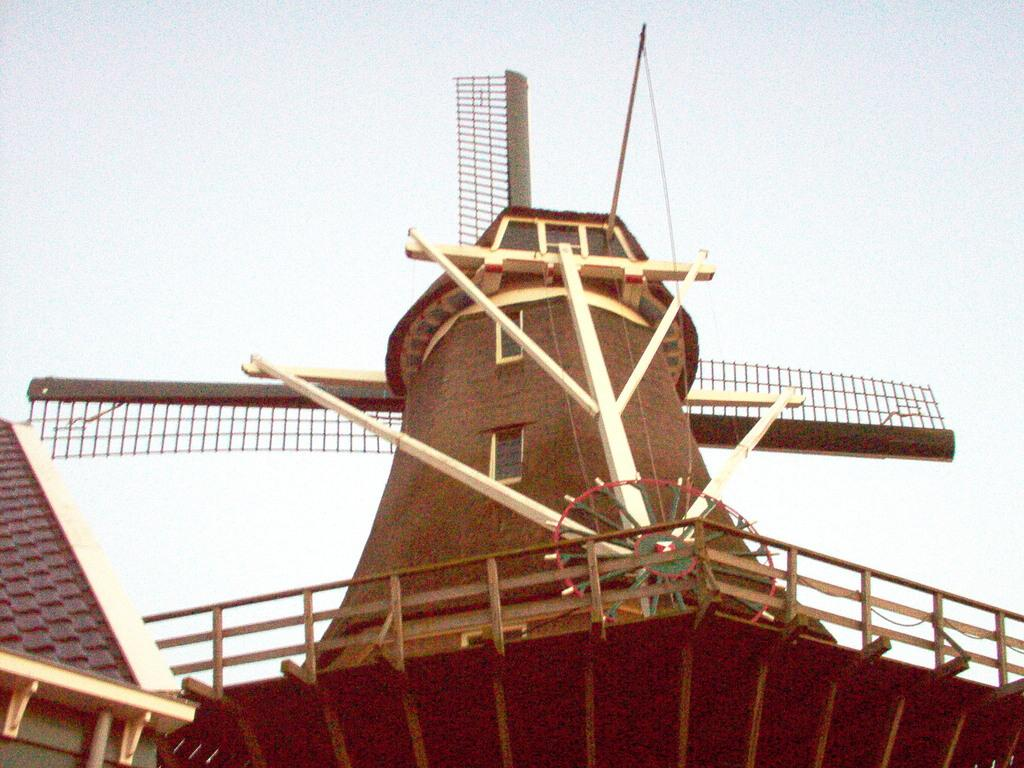What type of structures can be seen in the image? There are houses in the image. What color is the crayon used to draw the houses in the image? There is no crayon present in the image, as the houses are actual structures and not drawings. 